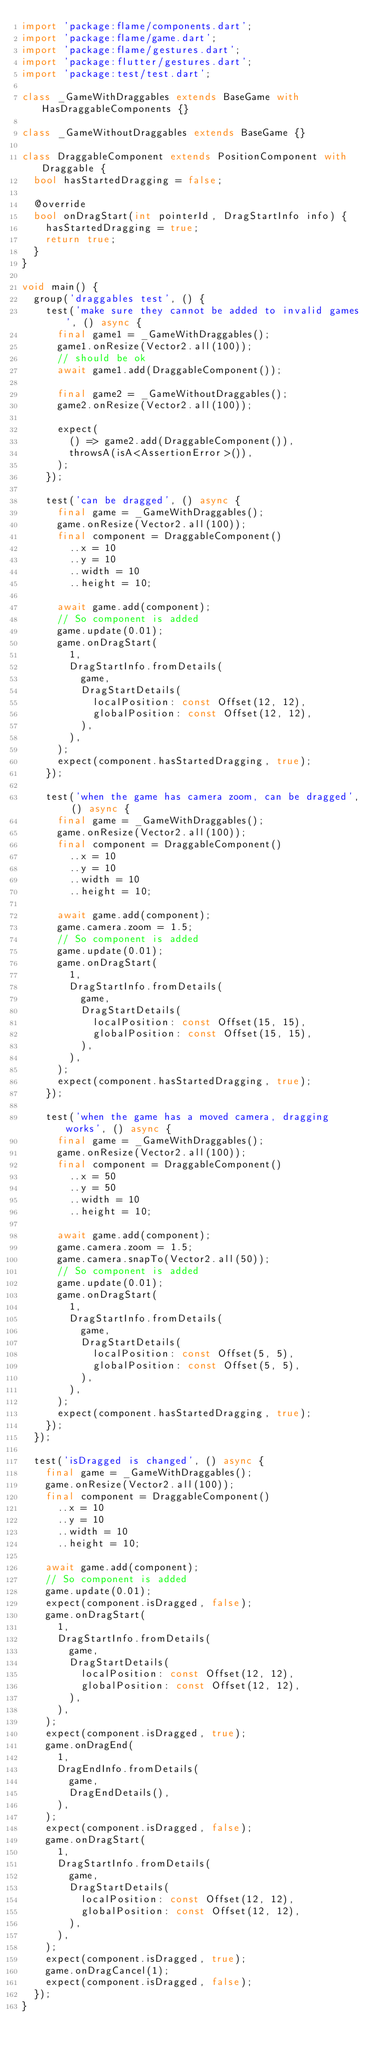<code> <loc_0><loc_0><loc_500><loc_500><_Dart_>import 'package:flame/components.dart';
import 'package:flame/game.dart';
import 'package:flame/gestures.dart';
import 'package:flutter/gestures.dart';
import 'package:test/test.dart';

class _GameWithDraggables extends BaseGame with HasDraggableComponents {}

class _GameWithoutDraggables extends BaseGame {}

class DraggableComponent extends PositionComponent with Draggable {
  bool hasStartedDragging = false;

  @override
  bool onDragStart(int pointerId, DragStartInfo info) {
    hasStartedDragging = true;
    return true;
  }
}

void main() {
  group('draggables test', () {
    test('make sure they cannot be added to invalid games', () async {
      final game1 = _GameWithDraggables();
      game1.onResize(Vector2.all(100));
      // should be ok
      await game1.add(DraggableComponent());

      final game2 = _GameWithoutDraggables();
      game2.onResize(Vector2.all(100));

      expect(
        () => game2.add(DraggableComponent()),
        throwsA(isA<AssertionError>()),
      );
    });

    test('can be dragged', () async {
      final game = _GameWithDraggables();
      game.onResize(Vector2.all(100));
      final component = DraggableComponent()
        ..x = 10
        ..y = 10
        ..width = 10
        ..height = 10;

      await game.add(component);
      // So component is added
      game.update(0.01);
      game.onDragStart(
        1,
        DragStartInfo.fromDetails(
          game,
          DragStartDetails(
            localPosition: const Offset(12, 12),
            globalPosition: const Offset(12, 12),
          ),
        ),
      );
      expect(component.hasStartedDragging, true);
    });

    test('when the game has camera zoom, can be dragged', () async {
      final game = _GameWithDraggables();
      game.onResize(Vector2.all(100));
      final component = DraggableComponent()
        ..x = 10
        ..y = 10
        ..width = 10
        ..height = 10;

      await game.add(component);
      game.camera.zoom = 1.5;
      // So component is added
      game.update(0.01);
      game.onDragStart(
        1,
        DragStartInfo.fromDetails(
          game,
          DragStartDetails(
            localPosition: const Offset(15, 15),
            globalPosition: const Offset(15, 15),
          ),
        ),
      );
      expect(component.hasStartedDragging, true);
    });

    test('when the game has a moved camera, dragging works', () async {
      final game = _GameWithDraggables();
      game.onResize(Vector2.all(100));
      final component = DraggableComponent()
        ..x = 50
        ..y = 50
        ..width = 10
        ..height = 10;

      await game.add(component);
      game.camera.zoom = 1.5;
      game.camera.snapTo(Vector2.all(50));
      // So component is added
      game.update(0.01);
      game.onDragStart(
        1,
        DragStartInfo.fromDetails(
          game,
          DragStartDetails(
            localPosition: const Offset(5, 5),
            globalPosition: const Offset(5, 5),
          ),
        ),
      );
      expect(component.hasStartedDragging, true);
    });
  });

  test('isDragged is changed', () async {
    final game = _GameWithDraggables();
    game.onResize(Vector2.all(100));
    final component = DraggableComponent()
      ..x = 10
      ..y = 10
      ..width = 10
      ..height = 10;

    await game.add(component);
    // So component is added
    game.update(0.01);
    expect(component.isDragged, false);
    game.onDragStart(
      1,
      DragStartInfo.fromDetails(
        game,
        DragStartDetails(
          localPosition: const Offset(12, 12),
          globalPosition: const Offset(12, 12),
        ),
      ),
    );
    expect(component.isDragged, true);
    game.onDragEnd(
      1,
      DragEndInfo.fromDetails(
        game,
        DragEndDetails(),
      ),
    );
    expect(component.isDragged, false);
    game.onDragStart(
      1,
      DragStartInfo.fromDetails(
        game,
        DragStartDetails(
          localPosition: const Offset(12, 12),
          globalPosition: const Offset(12, 12),
        ),
      ),
    );
    expect(component.isDragged, true);
    game.onDragCancel(1);
    expect(component.isDragged, false);
  });
}
</code> 